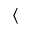<formula> <loc_0><loc_0><loc_500><loc_500>\langle</formula> 